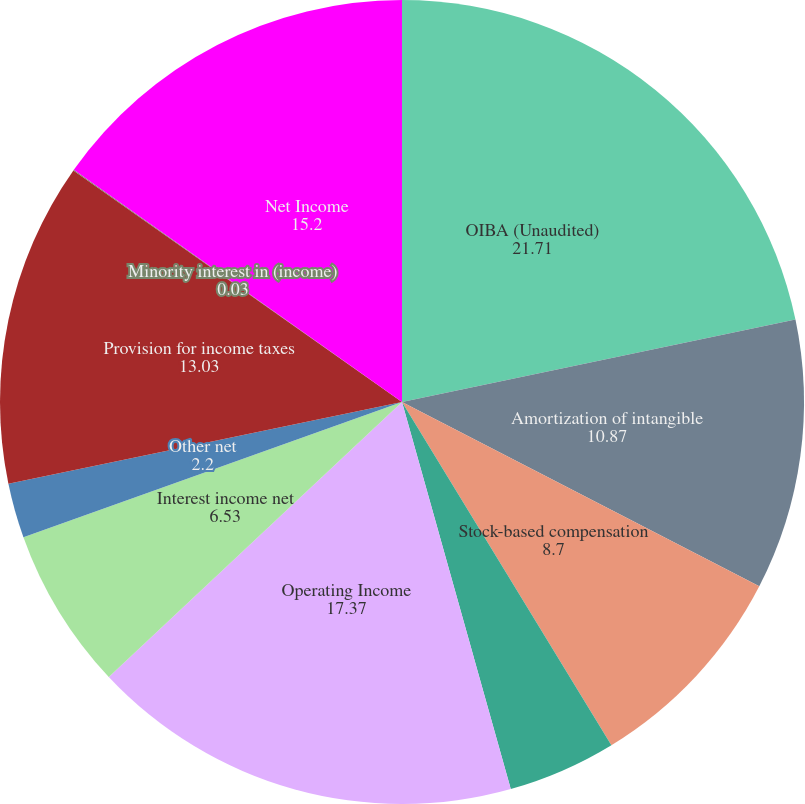Convert chart. <chart><loc_0><loc_0><loc_500><loc_500><pie_chart><fcel>OIBA (Unaudited)<fcel>Amortization of intangible<fcel>Stock-based compensation<fcel>Amortization of non-cash<fcel>Operating Income<fcel>Interest income net<fcel>Other net<fcel>Provision for income taxes<fcel>Minority interest in (income)<fcel>Net Income<nl><fcel>21.71%<fcel>10.87%<fcel>8.7%<fcel>4.36%<fcel>17.37%<fcel>6.53%<fcel>2.2%<fcel>13.03%<fcel>0.03%<fcel>15.2%<nl></chart> 